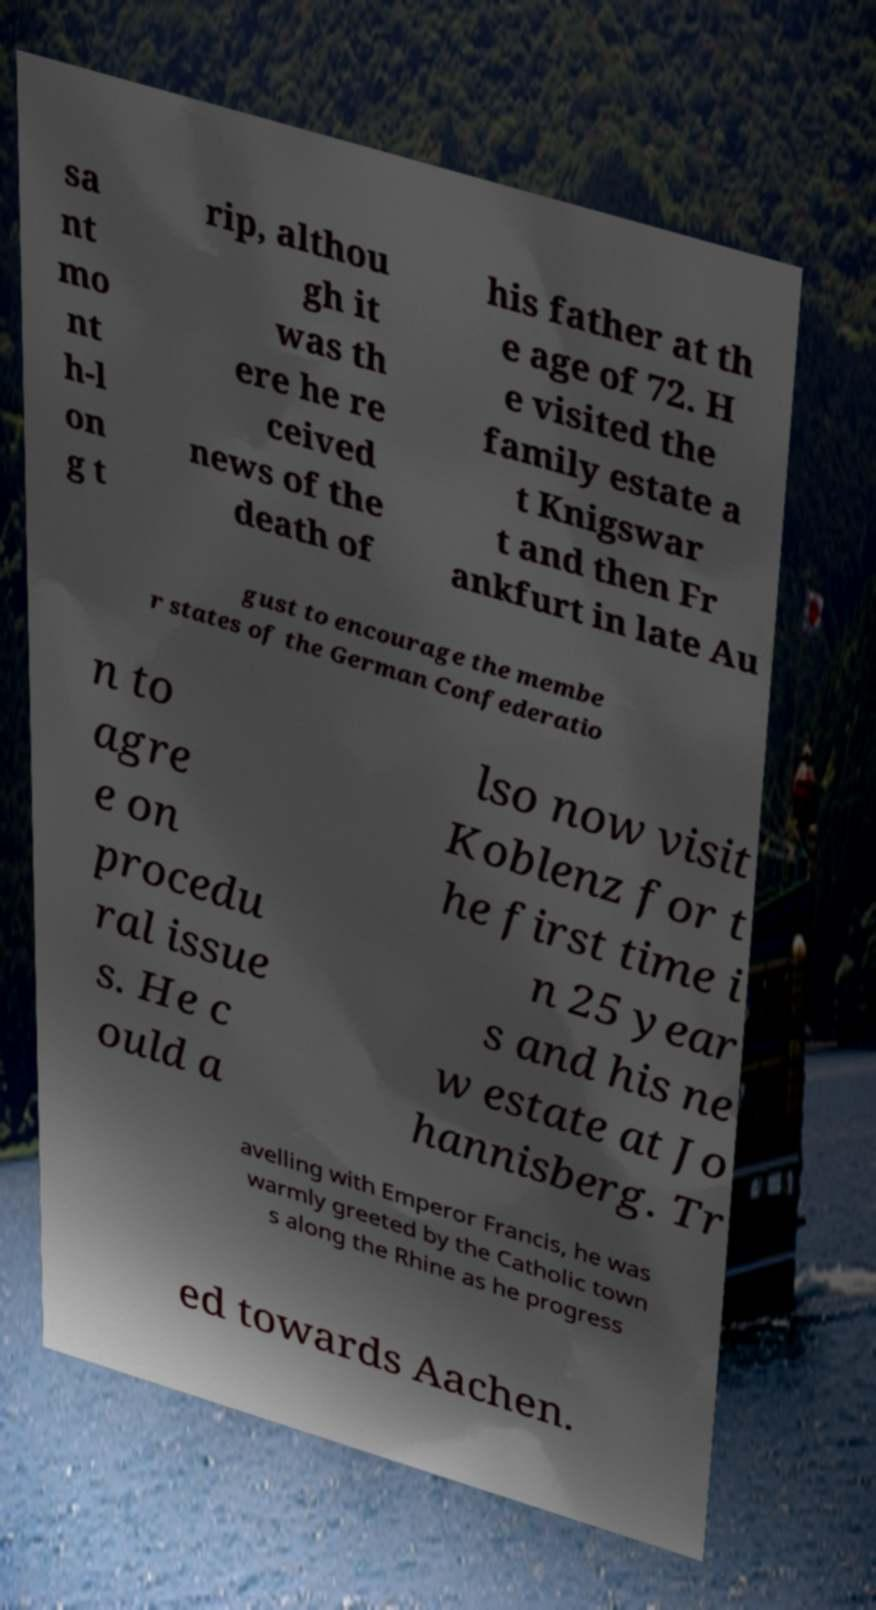Can you read and provide the text displayed in the image?This photo seems to have some interesting text. Can you extract and type it out for me? sa nt mo nt h-l on g t rip, althou gh it was th ere he re ceived news of the death of his father at th e age of 72. H e visited the family estate a t Knigswar t and then Fr ankfurt in late Au gust to encourage the membe r states of the German Confederatio n to agre e on procedu ral issue s. He c ould a lso now visit Koblenz for t he first time i n 25 year s and his ne w estate at Jo hannisberg. Tr avelling with Emperor Francis, he was warmly greeted by the Catholic town s along the Rhine as he progress ed towards Aachen. 